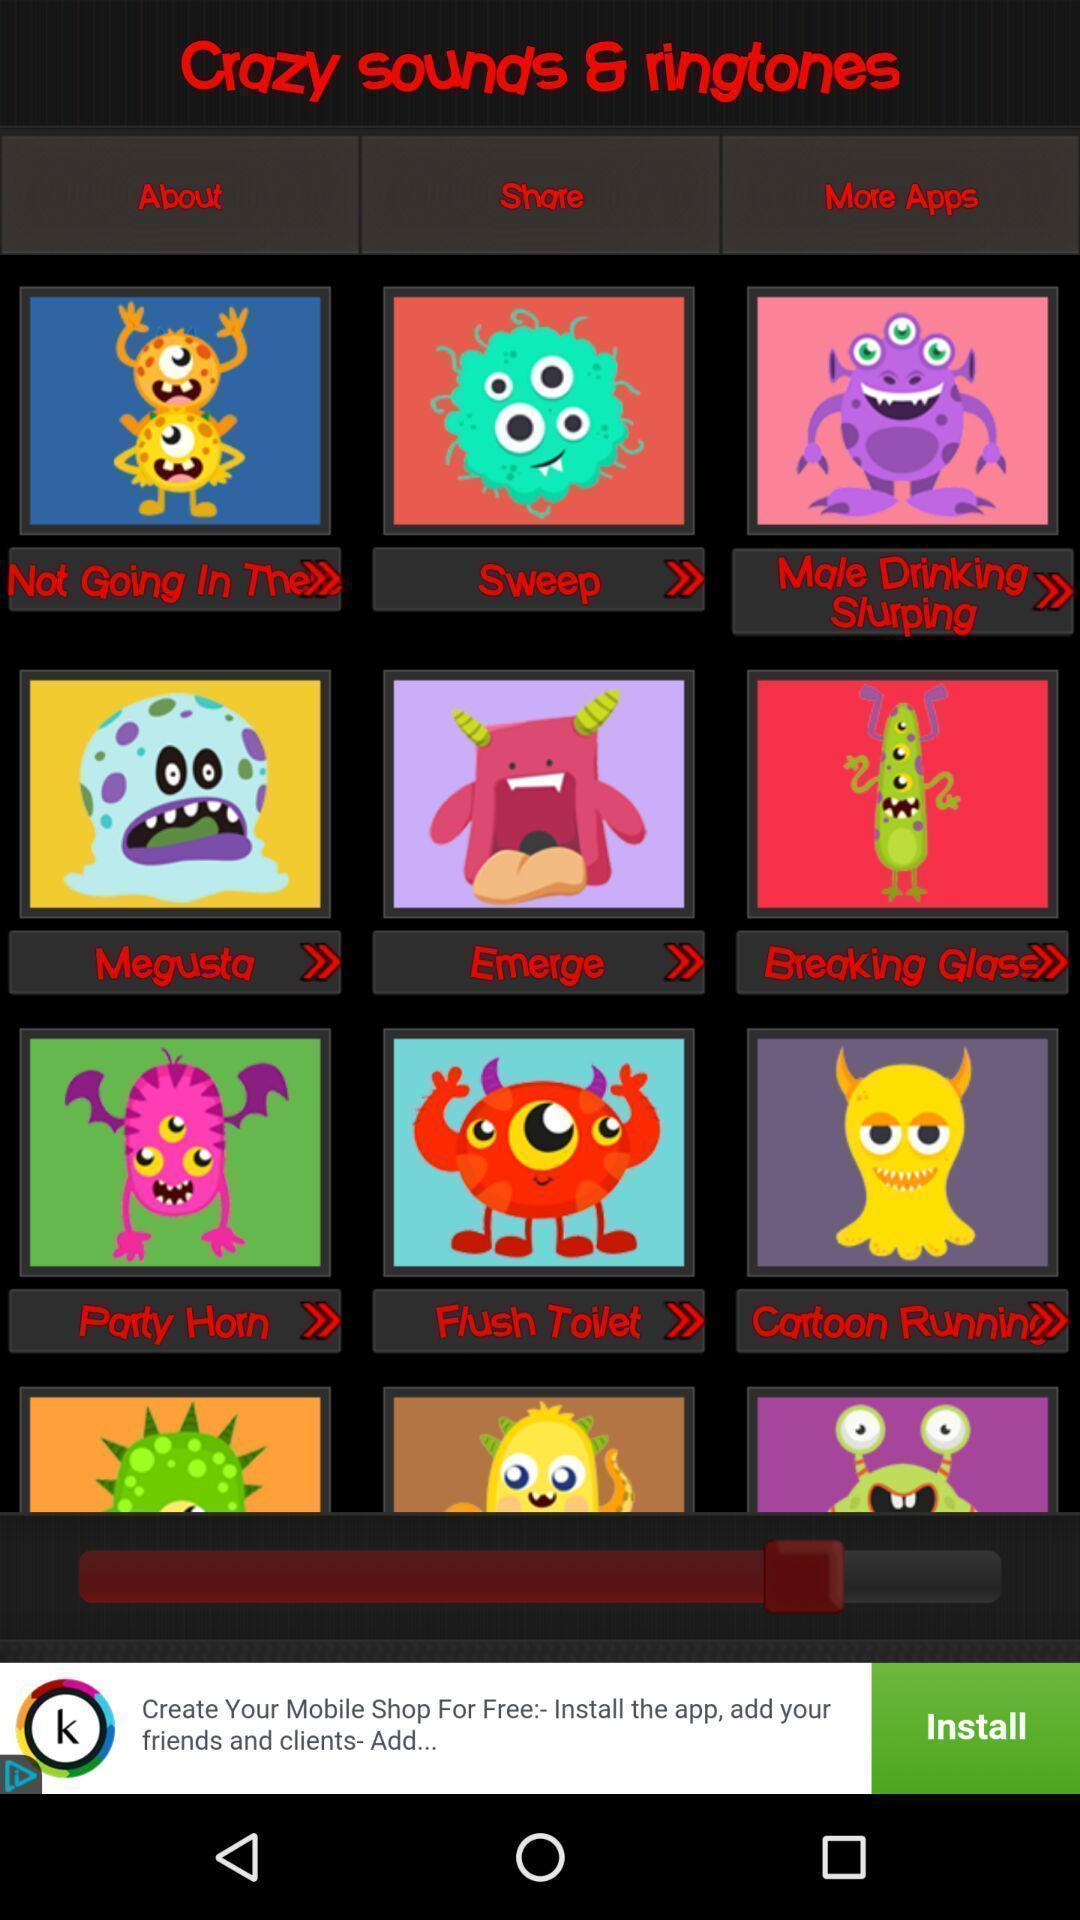Summarize the main components in this picture. Screen displaying multiple ringtone options with icons and names. 